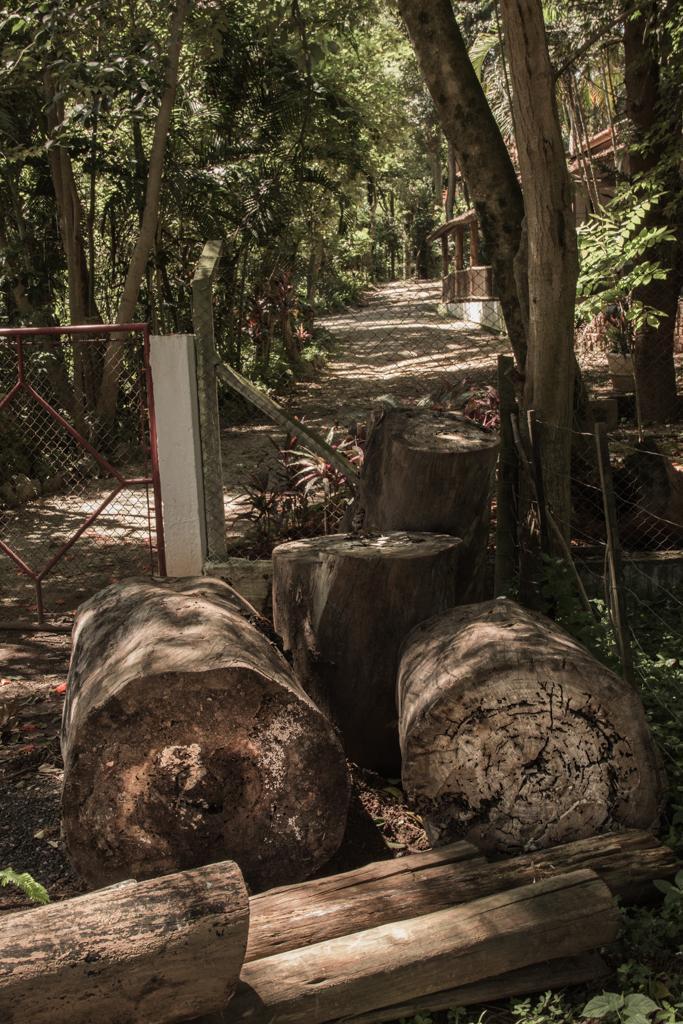Can you describe this image briefly? In this image, we can see wooden logs, plants, ground, mesh, poles and gate. Background we can see trees, poles, walkway, plants and railings. 